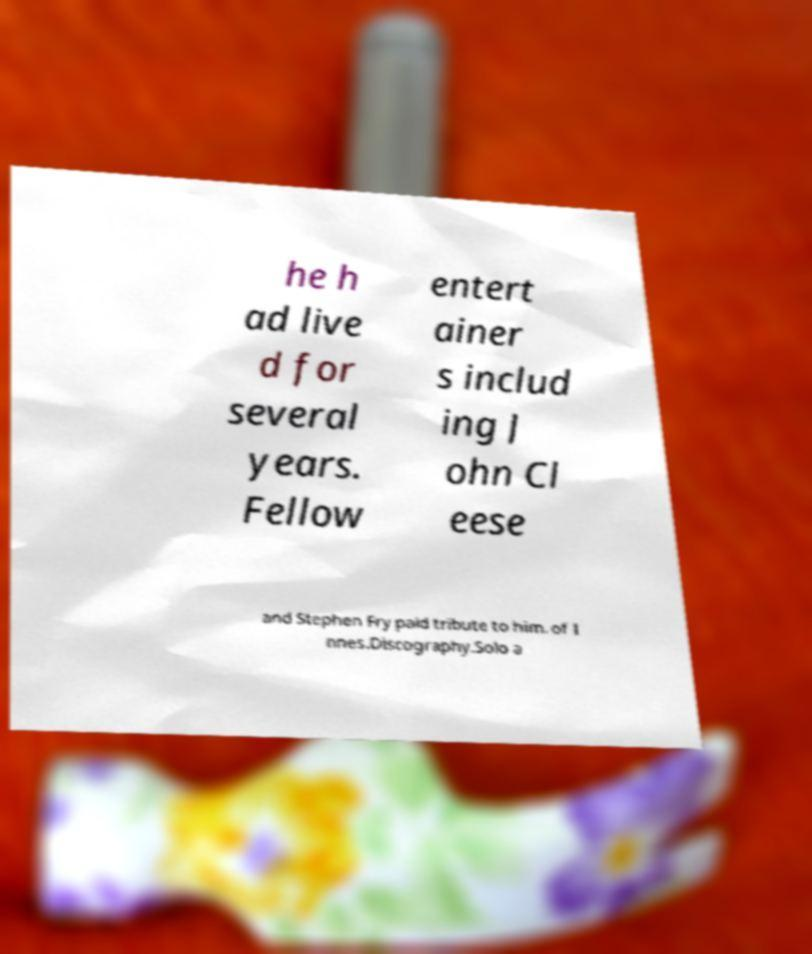I need the written content from this picture converted into text. Can you do that? he h ad live d for several years. Fellow entert ainer s includ ing J ohn Cl eese and Stephen Fry paid tribute to him. of I nnes.Discography.Solo a 